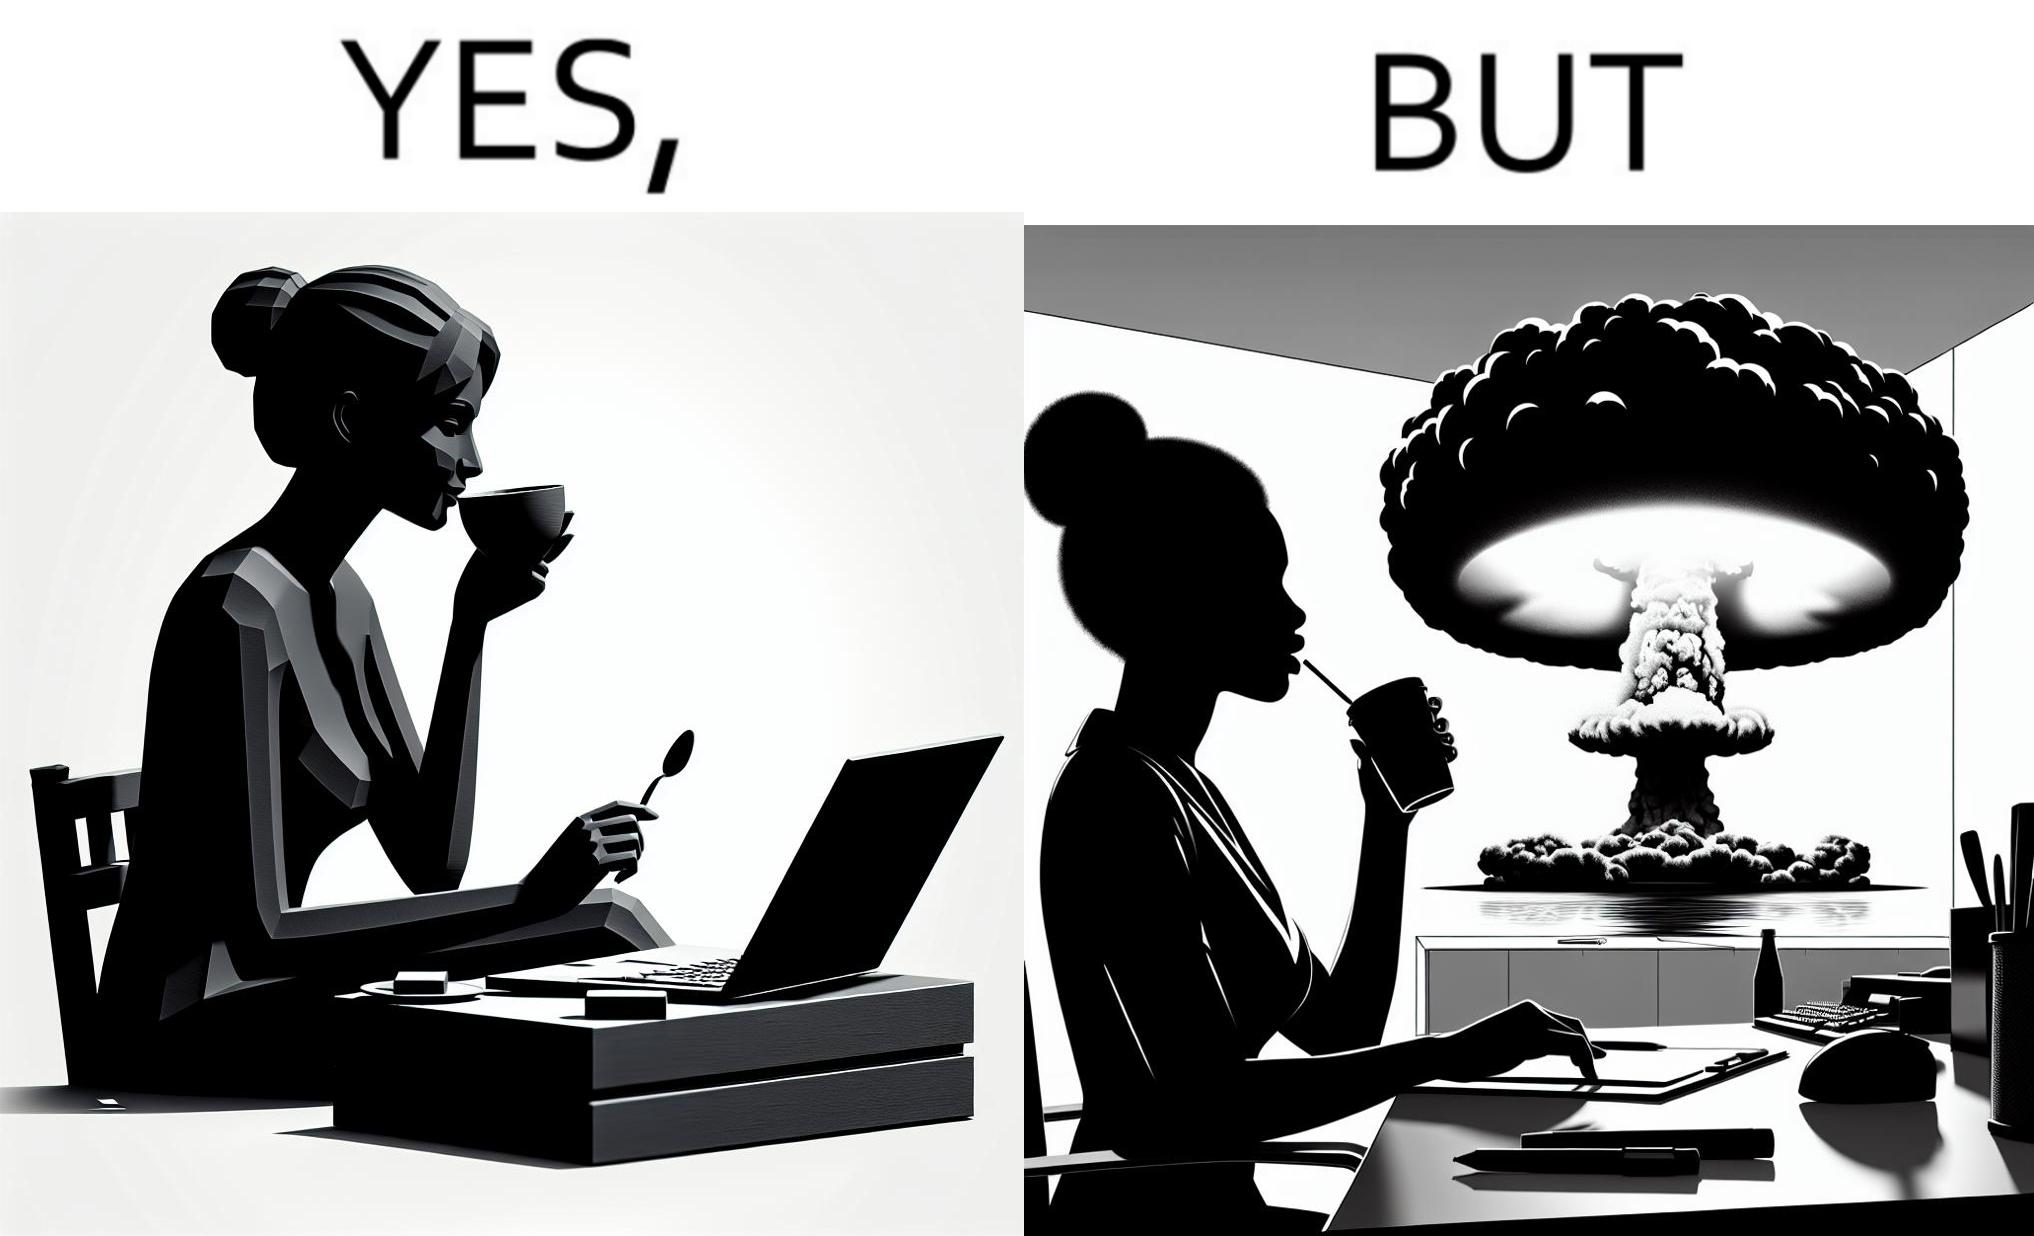What is shown in this image? The images are funny since it shows a woman simply sipping from a cup at ease in a cafe with her laptop not caring about anything going on outside the cafe even though the situation is very grave,that is, a nuclear blast 